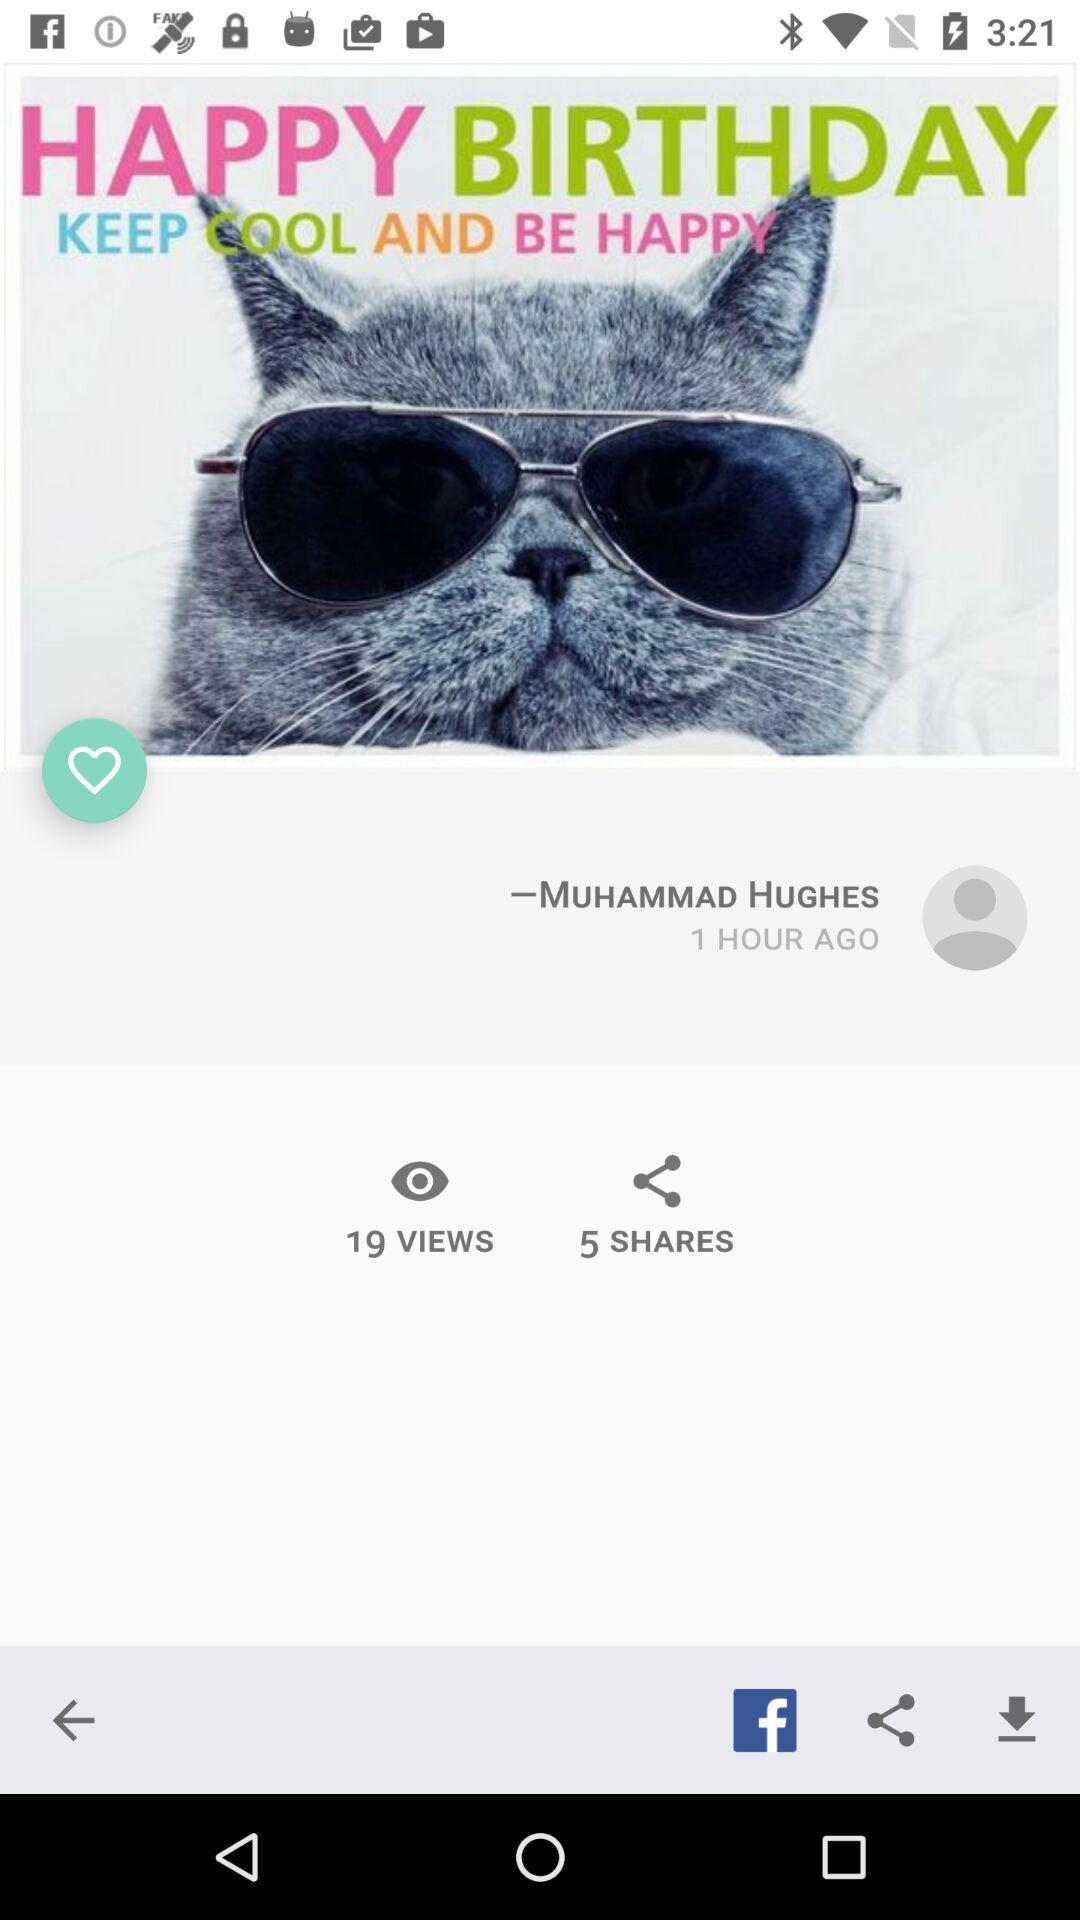How many shares are there? There are 5 shares. 